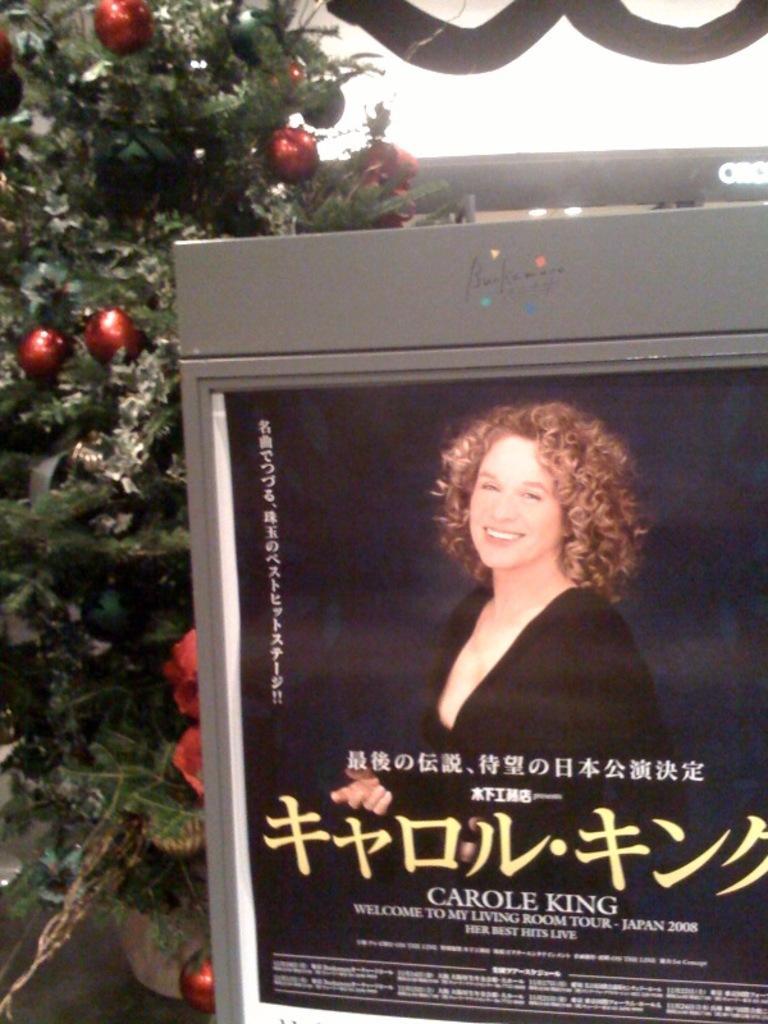Could you give a brief overview of what you see in this image? In this image we can see a digital display board which includes the image of a person and some text on it. And we can see the tree. 